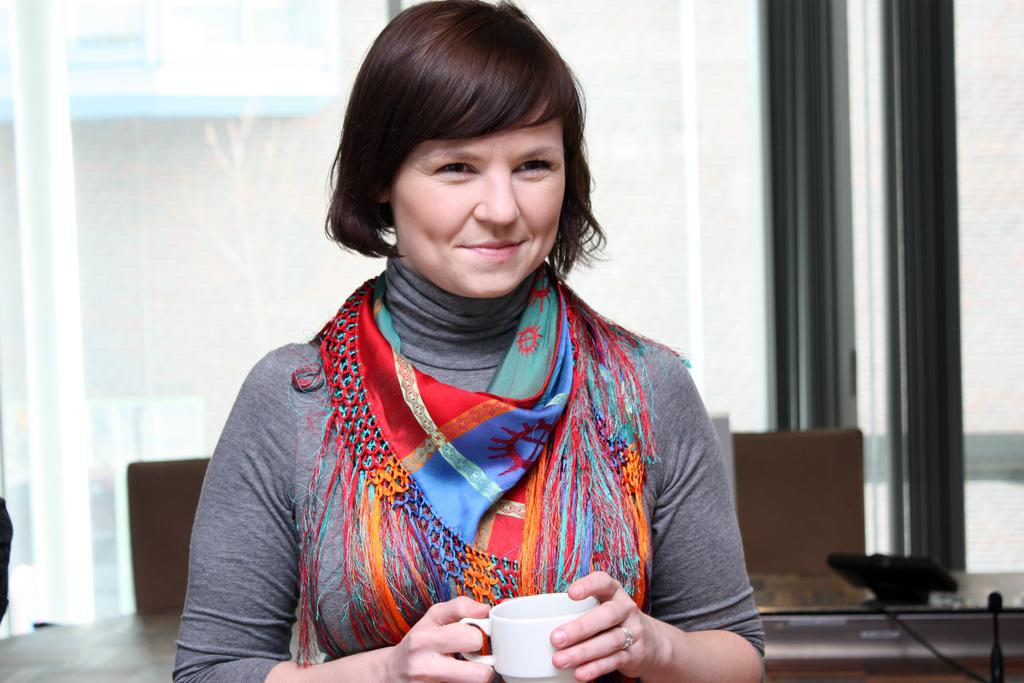Who or what is present in the image? There is a person in the image. What is the person's facial expression? The person is smiling. What is the person holding in the image? The person is holding a cup. What can be seen in the background of the image? There is a table and a glass in the background. Where is the hen sitting in the image? There is no hen present in the image. What type of sail is attached to the person's clothing in the image? There is no sail present in the image. 